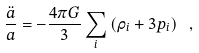Convert formula to latex. <formula><loc_0><loc_0><loc_500><loc_500>\frac { \ddot { a } } { a } = - \frac { 4 \pi G } { 3 } \sum _ { i } \left ( \rho _ { i } + 3 p _ { i } \right ) \ ,</formula> 